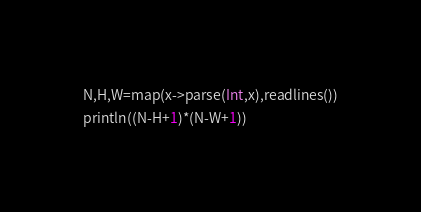<code> <loc_0><loc_0><loc_500><loc_500><_Julia_>N,H,W=map(x->parse(Int,x),readlines())
println((N-H+1)*(N-W+1))</code> 